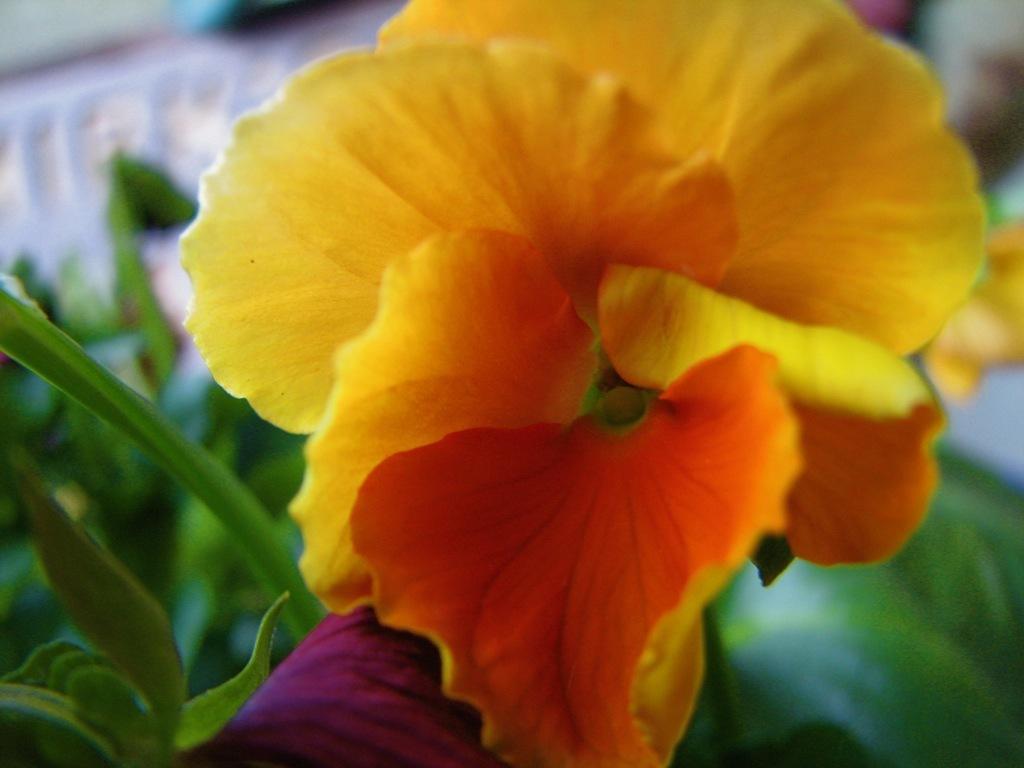Could you give a brief overview of what you see in this image? In this picture we can see a yellow flower and green leaves. 